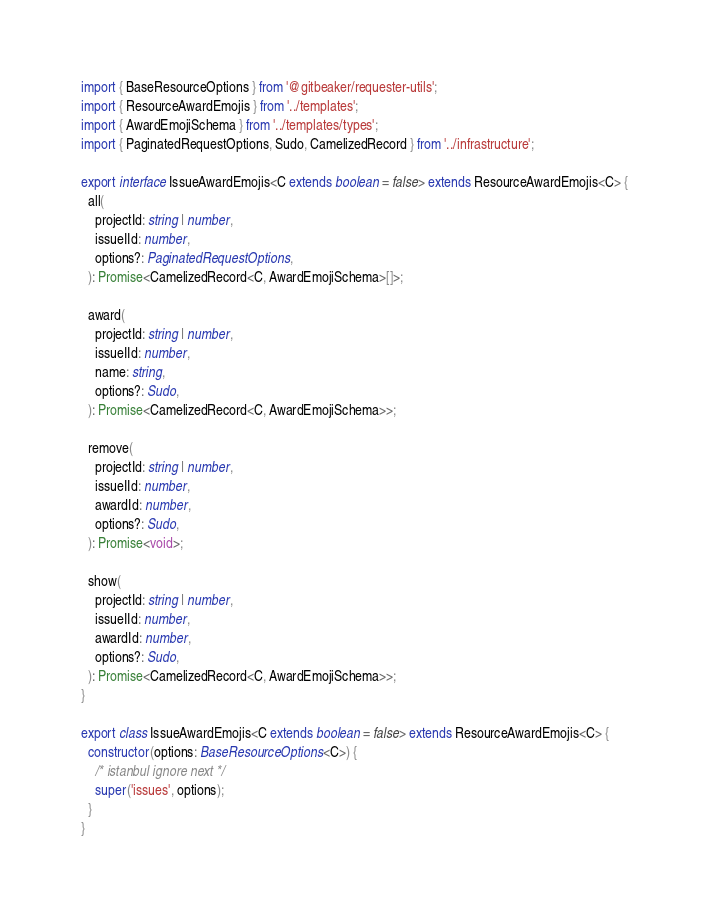Convert code to text. <code><loc_0><loc_0><loc_500><loc_500><_TypeScript_>import { BaseResourceOptions } from '@gitbeaker/requester-utils';
import { ResourceAwardEmojis } from '../templates';
import { AwardEmojiSchema } from '../templates/types';
import { PaginatedRequestOptions, Sudo, CamelizedRecord } from '../infrastructure';

export interface IssueAwardEmojis<C extends boolean = false> extends ResourceAwardEmojis<C> {
  all(
    projectId: string | number,
    issueIId: number,
    options?: PaginatedRequestOptions,
  ): Promise<CamelizedRecord<C, AwardEmojiSchema>[]>;

  award(
    projectId: string | number,
    issueIId: number,
    name: string,
    options?: Sudo,
  ): Promise<CamelizedRecord<C, AwardEmojiSchema>>;

  remove(
    projectId: string | number,
    issueIId: number,
    awardId: number,
    options?: Sudo,
  ): Promise<void>;

  show(
    projectId: string | number,
    issueIId: number,
    awardId: number,
    options?: Sudo,
  ): Promise<CamelizedRecord<C, AwardEmojiSchema>>;
}

export class IssueAwardEmojis<C extends boolean = false> extends ResourceAwardEmojis<C> {
  constructor(options: BaseResourceOptions<C>) {
    /* istanbul ignore next */
    super('issues', options);
  }
}
</code> 